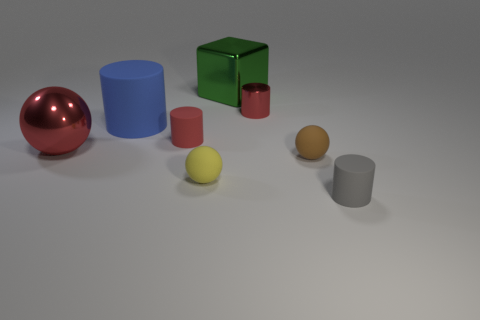Are there fewer rubber cylinders that are behind the metallic ball than large metallic balls?
Your response must be concise. No. How many red blocks are there?
Your answer should be compact. 0. Is the shape of the small red matte thing the same as the red object that is on the right side of the tiny yellow rubber object?
Provide a short and direct response. Yes. Are there fewer brown balls behind the large green thing than small red cylinders that are on the left side of the small gray rubber object?
Offer a very short reply. Yes. Is there anything else that is the same shape as the green object?
Provide a succinct answer. No. Is the brown rubber thing the same shape as the yellow thing?
Your answer should be very brief. Yes. The yellow rubber ball has what size?
Offer a terse response. Small. There is a shiny object that is both in front of the green object and behind the big blue rubber thing; what color is it?
Offer a very short reply. Red. Is the number of matte balls greater than the number of small rubber objects?
Make the answer very short. No. How many objects are either large red objects or things in front of the large green object?
Your response must be concise. 7. 